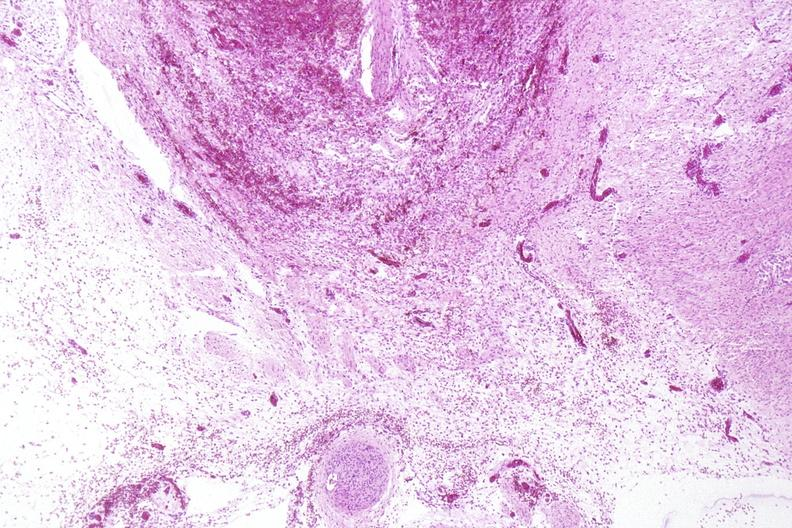what does this image show?
Answer the question using a single word or phrase. Neural tube defect 